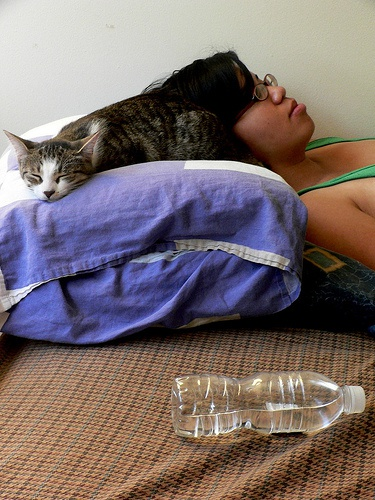Describe the objects in this image and their specific colors. I can see bed in lightgray, gray, black, and tan tones, people in lightgray, black, maroon, and brown tones, cat in lightgray, black, and gray tones, and bottle in lightgray, gray, tan, and darkgray tones in this image. 